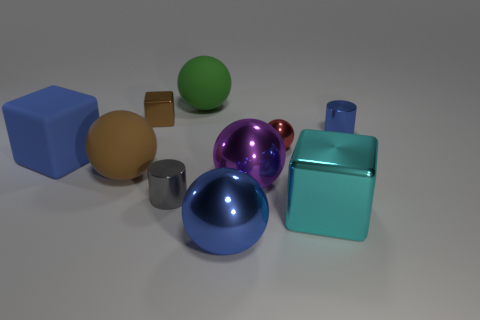What is the size of the rubber thing that is the same color as the small metallic block?
Keep it short and to the point. Large. Is the green thing made of the same material as the large brown thing?
Make the answer very short. Yes. What number of tiny cylinders have the same color as the big shiny block?
Your response must be concise. 0. Does the tiny shiny sphere have the same color as the big matte block?
Provide a short and direct response. No. What is the material of the gray object that is in front of the brown matte sphere?
Your answer should be very brief. Metal. What number of big things are gray cylinders or blue metallic blocks?
Your answer should be compact. 0. There is a large sphere that is the same color as the matte block; what is its material?
Provide a succinct answer. Metal. Are there any blocks made of the same material as the red object?
Your answer should be compact. Yes. Do the metal cylinder that is to the left of the green matte ball and the brown sphere have the same size?
Ensure brevity in your answer.  No. There is a brown object on the left side of the shiny cube that is to the left of the cyan metal cube; is there a tiny gray metallic cylinder that is in front of it?
Your response must be concise. Yes. 